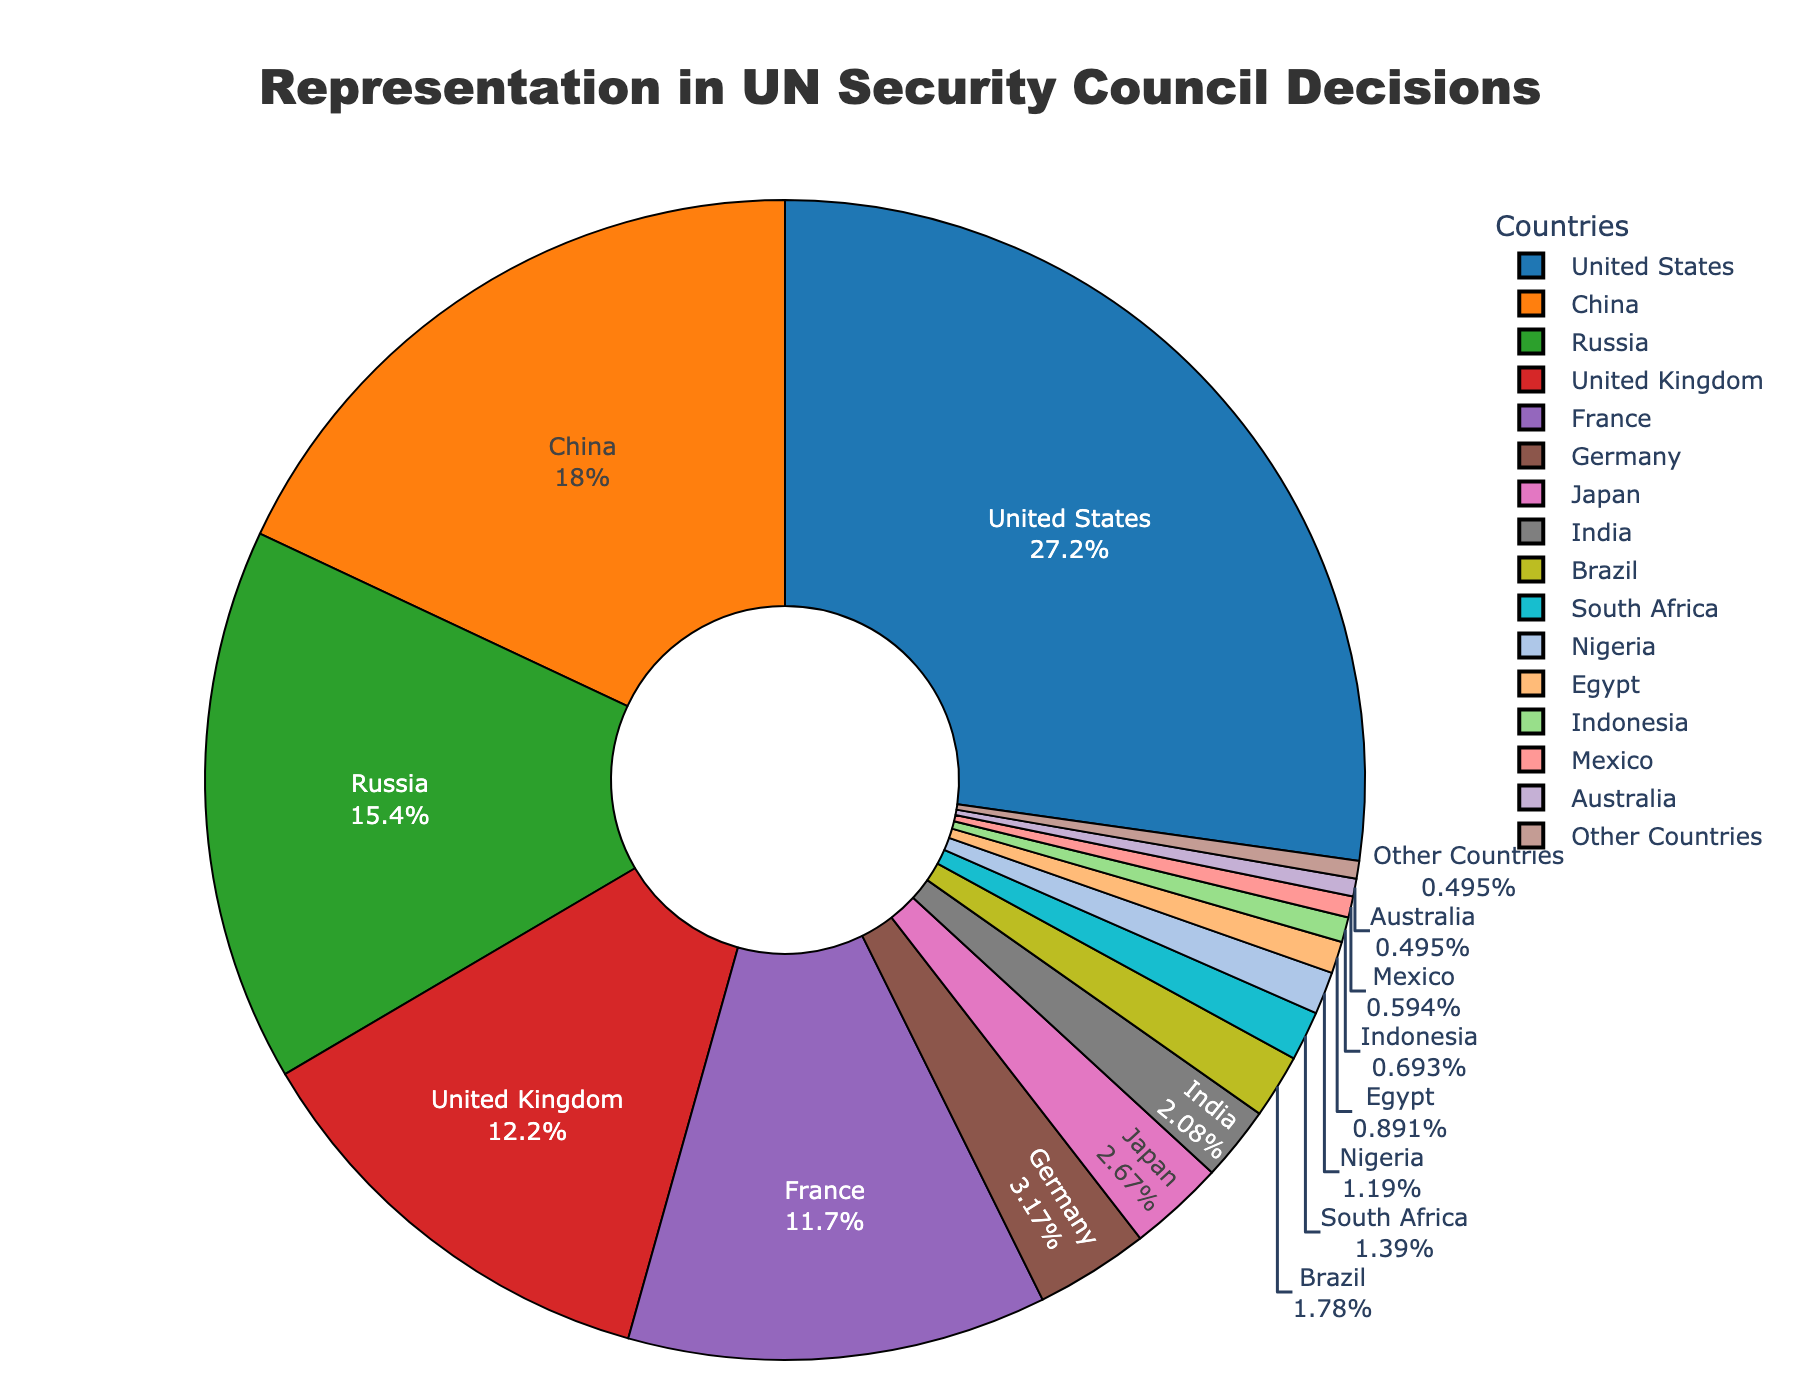Which country has the highest percentage of decisions involved in the UN Security Council? The country with the highest percentage can be identified by looking at the segment of the pie chart with the largest size and percentage label. In this case, it's shown as 27.5%.
Answer: United States What is the combined percentage of decisions involved by the P5 countries (United States, China, Russia, United Kingdom, France)? To find the combined percentage, sum the percentages of the P5 countries: 27.5% (United States) + 18.2% (China) + 15.6% (Russia) + 12.3% (United Kingdom) + 11.8% (France).
Answer: 85.4% Which three countries have the lowest representation in the UN Security Council decisions, and what is their combined percentage? The three countries with the smallest segments indicating the lowest percentage are identified by their minimal size and percentage values. These countries are Australia (0.5%), Mexico (0.6%), and Indonesia (0.7%). Summing these gives 0.5% + 0.6% + 0.7%.
Answer: 1.8% How does Germany’s representation compare to Japan’s? By comparing the sizes and percentages of Germany and Japan’s segments, Germany has 3.2%, while Japan has 2.7%. Germany's percentage is greater.
Answer: Germany has a higher representation than Japan What is the total percentage of decisions involved by countries outside the P5 and Germany, based on the legend? First sum the percentages of the P5 (85.4%) and Germany (3.2%), then subtract from 100% to find the representation of the other countries. 100% - 85.4% - 3.2%.
Answer: 11.4% Which country, represented by a violet-colored segment, has its percentage in UN Security Council decisions? By identifying the violet segment in the pie chart, it corresponds to France's section.
Answer: France What is the difference in representation percentage between Russia and the United Kingdom in the UN Security Council decisions? Subtract the percentage of the United Kingdom from that of Russia: 15.6% - 12.3%.
Answer: 3.3% What is the sum of the percentages of the countries represented in the UN Security Council decisions that have more than 10% but less than 20% representation? Identify countries within the 10%-20% range: China (18.2%) and Russia (15.6%), then sum their percentages: 18.2% + 15.6%.
Answer: 33.8% How much larger is the percentage share of the United States compared to China in the UN Security Council decisions? Subtract the percentage of China from the percentage of the United States: 27.5% - 18.2%.
Answer: 9.3% What color represents Brazil, and what is its percentage of decisions involved in the UN Security Council? Locate the segment for Brazil on the pie chart by its label, and note its color and percentage sign. Brazil is represented by a specific color with a 1.8% label.
Answer: Brazil is represented by olive color, 1.8% 